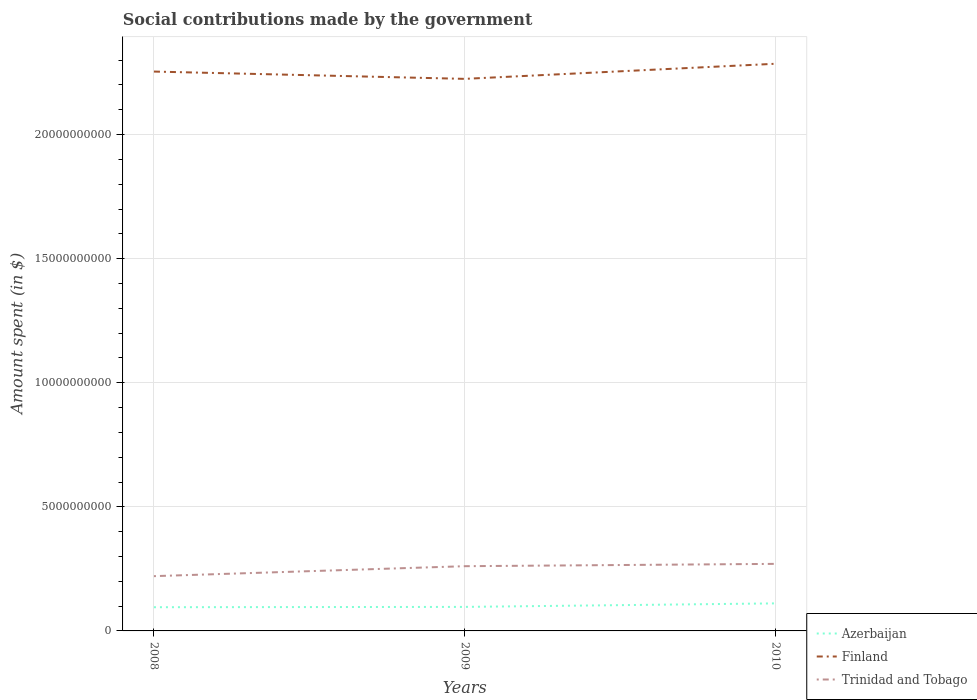Does the line corresponding to Azerbaijan intersect with the line corresponding to Finland?
Make the answer very short. No. Is the number of lines equal to the number of legend labels?
Keep it short and to the point. Yes. Across all years, what is the maximum amount spent on social contributions in Finland?
Your answer should be very brief. 2.22e+1. What is the total amount spent on social contributions in Finland in the graph?
Offer a terse response. -3.15e+08. What is the difference between the highest and the second highest amount spent on social contributions in Finland?
Your response must be concise. 6.09e+08. What is the difference between the highest and the lowest amount spent on social contributions in Trinidad and Tobago?
Offer a terse response. 2. Is the amount spent on social contributions in Azerbaijan strictly greater than the amount spent on social contributions in Finland over the years?
Offer a terse response. Yes. What is the difference between two consecutive major ticks on the Y-axis?
Give a very brief answer. 5.00e+09. Does the graph contain any zero values?
Make the answer very short. No. How are the legend labels stacked?
Your response must be concise. Vertical. What is the title of the graph?
Your response must be concise. Social contributions made by the government. What is the label or title of the Y-axis?
Give a very brief answer. Amount spent (in $). What is the Amount spent (in $) in Azerbaijan in 2008?
Your answer should be very brief. 9.55e+08. What is the Amount spent (in $) of Finland in 2008?
Keep it short and to the point. 2.25e+1. What is the Amount spent (in $) of Trinidad and Tobago in 2008?
Offer a terse response. 2.21e+09. What is the Amount spent (in $) in Azerbaijan in 2009?
Ensure brevity in your answer.  9.68e+08. What is the Amount spent (in $) in Finland in 2009?
Your answer should be compact. 2.22e+1. What is the Amount spent (in $) of Trinidad and Tobago in 2009?
Give a very brief answer. 2.61e+09. What is the Amount spent (in $) of Azerbaijan in 2010?
Give a very brief answer. 1.11e+09. What is the Amount spent (in $) of Finland in 2010?
Ensure brevity in your answer.  2.29e+1. What is the Amount spent (in $) of Trinidad and Tobago in 2010?
Ensure brevity in your answer.  2.70e+09. Across all years, what is the maximum Amount spent (in $) in Azerbaijan?
Give a very brief answer. 1.11e+09. Across all years, what is the maximum Amount spent (in $) of Finland?
Provide a short and direct response. 2.29e+1. Across all years, what is the maximum Amount spent (in $) of Trinidad and Tobago?
Provide a short and direct response. 2.70e+09. Across all years, what is the minimum Amount spent (in $) in Azerbaijan?
Ensure brevity in your answer.  9.55e+08. Across all years, what is the minimum Amount spent (in $) of Finland?
Offer a very short reply. 2.22e+1. Across all years, what is the minimum Amount spent (in $) in Trinidad and Tobago?
Your answer should be very brief. 2.21e+09. What is the total Amount spent (in $) of Azerbaijan in the graph?
Make the answer very short. 3.03e+09. What is the total Amount spent (in $) of Finland in the graph?
Make the answer very short. 6.76e+1. What is the total Amount spent (in $) of Trinidad and Tobago in the graph?
Your answer should be compact. 7.52e+09. What is the difference between the Amount spent (in $) of Azerbaijan in 2008 and that in 2009?
Your answer should be compact. -1.26e+07. What is the difference between the Amount spent (in $) in Finland in 2008 and that in 2009?
Offer a very short reply. 2.94e+08. What is the difference between the Amount spent (in $) in Trinidad and Tobago in 2008 and that in 2009?
Your answer should be compact. -4.01e+08. What is the difference between the Amount spent (in $) of Azerbaijan in 2008 and that in 2010?
Offer a very short reply. -1.55e+08. What is the difference between the Amount spent (in $) in Finland in 2008 and that in 2010?
Your answer should be compact. -3.15e+08. What is the difference between the Amount spent (in $) in Trinidad and Tobago in 2008 and that in 2010?
Offer a very short reply. -4.95e+08. What is the difference between the Amount spent (in $) of Azerbaijan in 2009 and that in 2010?
Keep it short and to the point. -1.42e+08. What is the difference between the Amount spent (in $) of Finland in 2009 and that in 2010?
Offer a terse response. -6.09e+08. What is the difference between the Amount spent (in $) of Trinidad and Tobago in 2009 and that in 2010?
Ensure brevity in your answer.  -9.38e+07. What is the difference between the Amount spent (in $) of Azerbaijan in 2008 and the Amount spent (in $) of Finland in 2009?
Make the answer very short. -2.13e+1. What is the difference between the Amount spent (in $) in Azerbaijan in 2008 and the Amount spent (in $) in Trinidad and Tobago in 2009?
Give a very brief answer. -1.65e+09. What is the difference between the Amount spent (in $) of Finland in 2008 and the Amount spent (in $) of Trinidad and Tobago in 2009?
Your answer should be very brief. 1.99e+1. What is the difference between the Amount spent (in $) in Azerbaijan in 2008 and the Amount spent (in $) in Finland in 2010?
Your response must be concise. -2.19e+1. What is the difference between the Amount spent (in $) of Azerbaijan in 2008 and the Amount spent (in $) of Trinidad and Tobago in 2010?
Provide a succinct answer. -1.75e+09. What is the difference between the Amount spent (in $) of Finland in 2008 and the Amount spent (in $) of Trinidad and Tobago in 2010?
Give a very brief answer. 1.98e+1. What is the difference between the Amount spent (in $) in Azerbaijan in 2009 and the Amount spent (in $) in Finland in 2010?
Make the answer very short. -2.19e+1. What is the difference between the Amount spent (in $) of Azerbaijan in 2009 and the Amount spent (in $) of Trinidad and Tobago in 2010?
Provide a short and direct response. -1.73e+09. What is the difference between the Amount spent (in $) of Finland in 2009 and the Amount spent (in $) of Trinidad and Tobago in 2010?
Make the answer very short. 1.95e+1. What is the average Amount spent (in $) in Azerbaijan per year?
Ensure brevity in your answer.  1.01e+09. What is the average Amount spent (in $) in Finland per year?
Offer a terse response. 2.25e+1. What is the average Amount spent (in $) of Trinidad and Tobago per year?
Your answer should be very brief. 2.51e+09. In the year 2008, what is the difference between the Amount spent (in $) of Azerbaijan and Amount spent (in $) of Finland?
Make the answer very short. -2.16e+1. In the year 2008, what is the difference between the Amount spent (in $) in Azerbaijan and Amount spent (in $) in Trinidad and Tobago?
Offer a very short reply. -1.25e+09. In the year 2008, what is the difference between the Amount spent (in $) of Finland and Amount spent (in $) of Trinidad and Tobago?
Ensure brevity in your answer.  2.03e+1. In the year 2009, what is the difference between the Amount spent (in $) of Azerbaijan and Amount spent (in $) of Finland?
Provide a succinct answer. -2.13e+1. In the year 2009, what is the difference between the Amount spent (in $) in Azerbaijan and Amount spent (in $) in Trinidad and Tobago?
Your response must be concise. -1.64e+09. In the year 2009, what is the difference between the Amount spent (in $) in Finland and Amount spent (in $) in Trinidad and Tobago?
Make the answer very short. 1.96e+1. In the year 2010, what is the difference between the Amount spent (in $) in Azerbaijan and Amount spent (in $) in Finland?
Provide a short and direct response. -2.17e+1. In the year 2010, what is the difference between the Amount spent (in $) in Azerbaijan and Amount spent (in $) in Trinidad and Tobago?
Ensure brevity in your answer.  -1.59e+09. In the year 2010, what is the difference between the Amount spent (in $) in Finland and Amount spent (in $) in Trinidad and Tobago?
Make the answer very short. 2.02e+1. What is the ratio of the Amount spent (in $) of Azerbaijan in 2008 to that in 2009?
Provide a short and direct response. 0.99. What is the ratio of the Amount spent (in $) in Finland in 2008 to that in 2009?
Offer a terse response. 1.01. What is the ratio of the Amount spent (in $) in Trinidad and Tobago in 2008 to that in 2009?
Ensure brevity in your answer.  0.85. What is the ratio of the Amount spent (in $) of Azerbaijan in 2008 to that in 2010?
Your response must be concise. 0.86. What is the ratio of the Amount spent (in $) of Finland in 2008 to that in 2010?
Keep it short and to the point. 0.99. What is the ratio of the Amount spent (in $) in Trinidad and Tobago in 2008 to that in 2010?
Make the answer very short. 0.82. What is the ratio of the Amount spent (in $) in Azerbaijan in 2009 to that in 2010?
Your answer should be very brief. 0.87. What is the ratio of the Amount spent (in $) of Finland in 2009 to that in 2010?
Ensure brevity in your answer.  0.97. What is the ratio of the Amount spent (in $) in Trinidad and Tobago in 2009 to that in 2010?
Your answer should be very brief. 0.97. What is the difference between the highest and the second highest Amount spent (in $) of Azerbaijan?
Provide a succinct answer. 1.42e+08. What is the difference between the highest and the second highest Amount spent (in $) of Finland?
Give a very brief answer. 3.15e+08. What is the difference between the highest and the second highest Amount spent (in $) of Trinidad and Tobago?
Keep it short and to the point. 9.38e+07. What is the difference between the highest and the lowest Amount spent (in $) of Azerbaijan?
Your answer should be compact. 1.55e+08. What is the difference between the highest and the lowest Amount spent (in $) of Finland?
Give a very brief answer. 6.09e+08. What is the difference between the highest and the lowest Amount spent (in $) of Trinidad and Tobago?
Keep it short and to the point. 4.95e+08. 